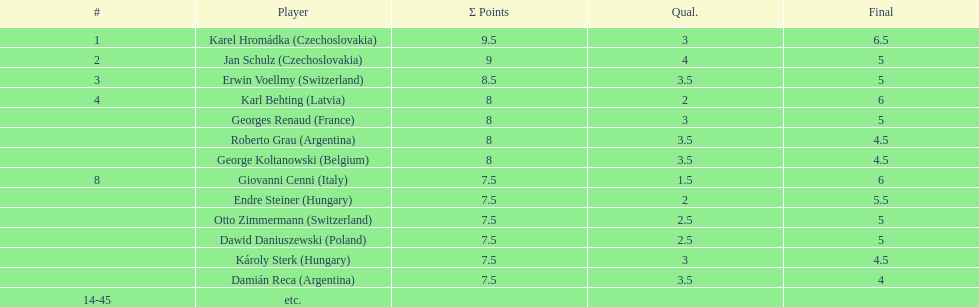I'm looking to parse the entire table for insights. Could you assist me with that? {'header': ['#', 'Player', 'Σ Points', 'Qual.', 'Final'], 'rows': [['1', 'Karel Hromádka\xa0(Czechoslovakia)', '9.5', '3', '6.5'], ['2', 'Jan Schulz\xa0(Czechoslovakia)', '9', '4', '5'], ['3', 'Erwin Voellmy\xa0(Switzerland)', '8.5', '3.5', '5'], ['4', 'Karl Behting\xa0(Latvia)', '8', '2', '6'], ['', 'Georges Renaud\xa0(France)', '8', '3', '5'], ['', 'Roberto Grau\xa0(Argentina)', '8', '3.5', '4.5'], ['', 'George Koltanowski\xa0(Belgium)', '8', '3.5', '4.5'], ['8', 'Giovanni Cenni\xa0(Italy)', '7.5', '1.5', '6'], ['', 'Endre Steiner\xa0(Hungary)', '7.5', '2', '5.5'], ['', 'Otto Zimmermann\xa0(Switzerland)', '7.5', '2.5', '5'], ['', 'Dawid Daniuszewski\xa0(Poland)', '7.5', '2.5', '5'], ['', 'Károly Sterk\xa0(Hungary)', '7.5', '3', '4.5'], ['', 'Damián Reca\xa0(Argentina)', '7.5', '3.5', '4'], ['14-45', 'etc.', '', '', '']]} How many players obtained final scores above 5? 4. 